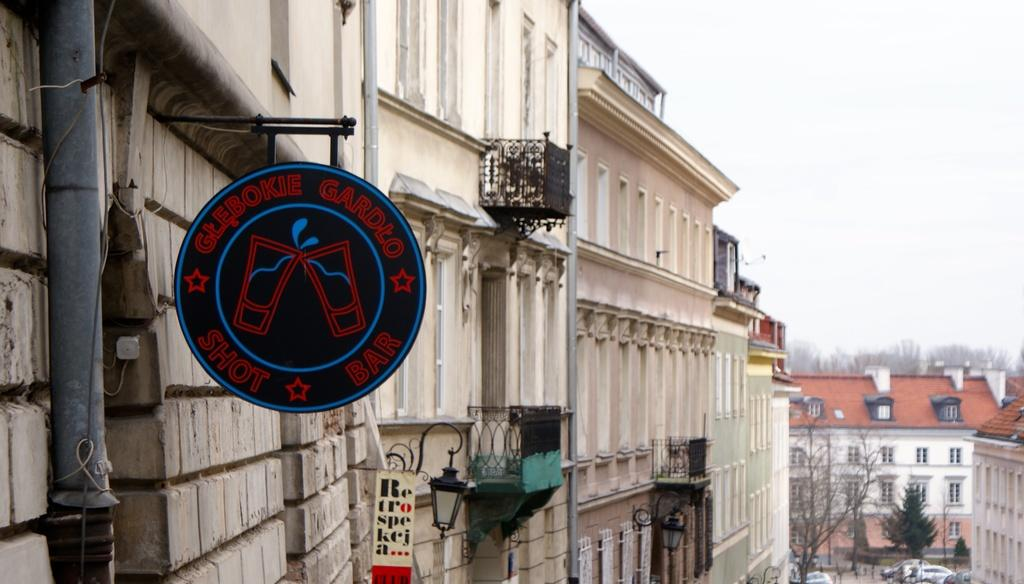What type of structures can be seen in the image? There are buildings in the image. What type of vegetation is present in the image? There are trees in the image. What type of vehicles can be seen in the image? There are cars in the image. What type of signage is present in the image? There are boards in the image. What type of vertical structures can be seen in the image? There are poles in the image. What is visible in the background of the image? The sky is visible in the background of the image. Can you tell me how many cows are grazing on the farm in the image? There is no farm or cows present in the image. What type of watch is the person wearing in the image? There is no person or watch visible in the image. 